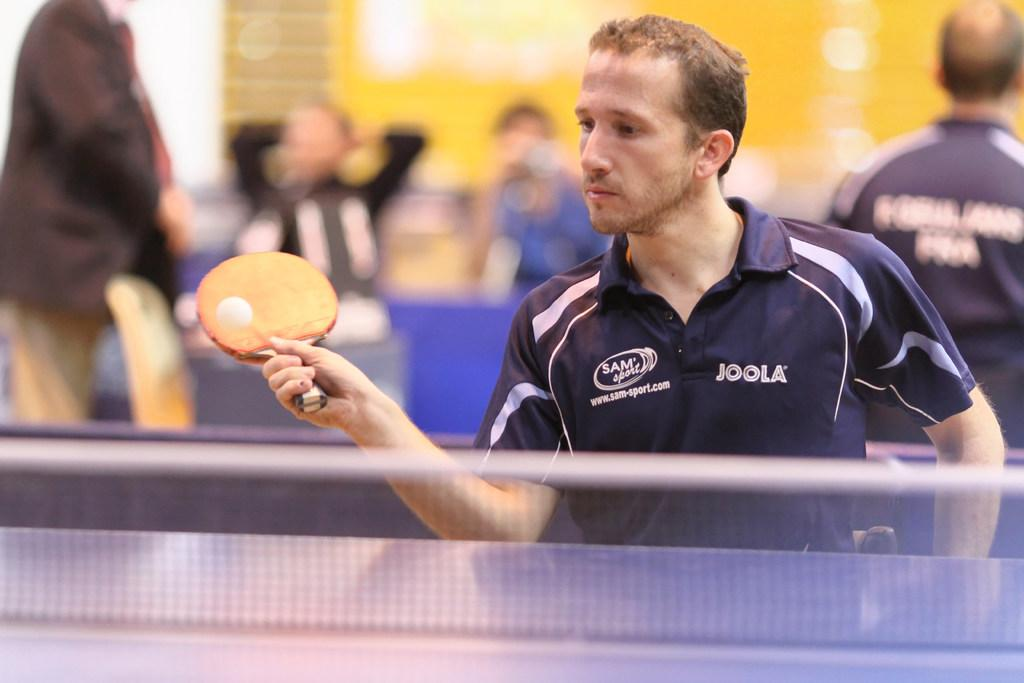<image>
Summarize the visual content of the image. A man wearing a Sam Sport Joola team shirt playing ping pong. 